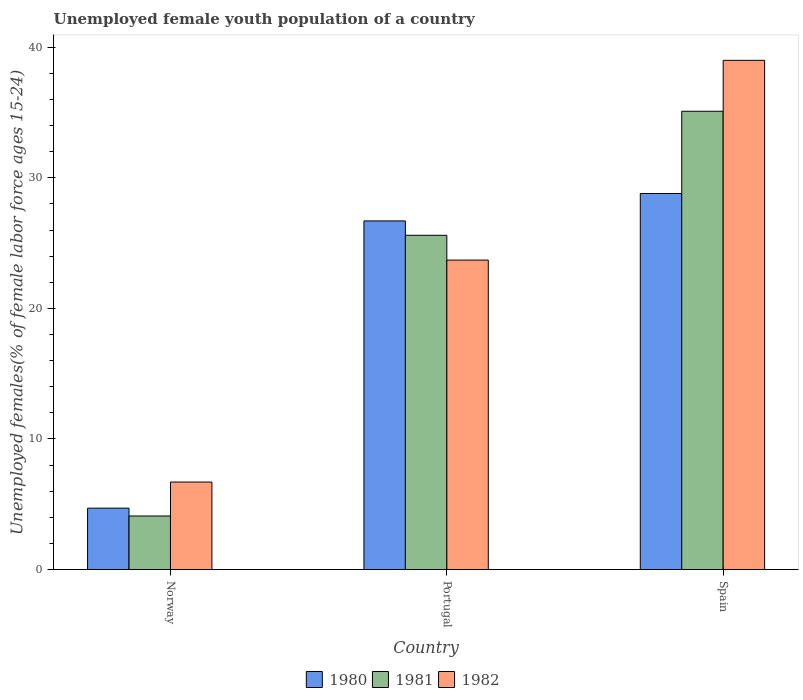Are the number of bars per tick equal to the number of legend labels?
Offer a very short reply. Yes. How many bars are there on the 1st tick from the left?
Offer a very short reply. 3. What is the percentage of unemployed female youth population in 1980 in Spain?
Your answer should be very brief. 28.8. Across all countries, what is the maximum percentage of unemployed female youth population in 1982?
Provide a short and direct response. 39. Across all countries, what is the minimum percentage of unemployed female youth population in 1982?
Your answer should be very brief. 6.7. In which country was the percentage of unemployed female youth population in 1981 maximum?
Offer a terse response. Spain. What is the total percentage of unemployed female youth population in 1980 in the graph?
Offer a terse response. 60.2. What is the difference between the percentage of unemployed female youth population in 1980 in Norway and that in Portugal?
Your response must be concise. -22. What is the difference between the percentage of unemployed female youth population in 1982 in Portugal and the percentage of unemployed female youth population in 1980 in Norway?
Your response must be concise. 19. What is the average percentage of unemployed female youth population in 1980 per country?
Offer a very short reply. 20.07. What is the difference between the percentage of unemployed female youth population of/in 1982 and percentage of unemployed female youth population of/in 1981 in Norway?
Your answer should be very brief. 2.6. In how many countries, is the percentage of unemployed female youth population in 1980 greater than 6 %?
Provide a succinct answer. 2. What is the ratio of the percentage of unemployed female youth population in 1980 in Norway to that in Portugal?
Make the answer very short. 0.18. Is the percentage of unemployed female youth population in 1981 in Portugal less than that in Spain?
Keep it short and to the point. Yes. Is the difference between the percentage of unemployed female youth population in 1982 in Norway and Portugal greater than the difference between the percentage of unemployed female youth population in 1981 in Norway and Portugal?
Keep it short and to the point. Yes. What is the difference between the highest and the second highest percentage of unemployed female youth population in 1981?
Ensure brevity in your answer.  -9.5. What is the difference between the highest and the lowest percentage of unemployed female youth population in 1980?
Your answer should be compact. 24.1. Is the sum of the percentage of unemployed female youth population in 1980 in Portugal and Spain greater than the maximum percentage of unemployed female youth population in 1981 across all countries?
Give a very brief answer. Yes. What does the 2nd bar from the left in Portugal represents?
Offer a terse response. 1981. Is it the case that in every country, the sum of the percentage of unemployed female youth population in 1980 and percentage of unemployed female youth population in 1982 is greater than the percentage of unemployed female youth population in 1981?
Your response must be concise. Yes. How many bars are there?
Your answer should be very brief. 9. How many countries are there in the graph?
Your answer should be compact. 3. Does the graph contain grids?
Give a very brief answer. No. How many legend labels are there?
Your response must be concise. 3. What is the title of the graph?
Your response must be concise. Unemployed female youth population of a country. Does "1966" appear as one of the legend labels in the graph?
Your answer should be compact. No. What is the label or title of the X-axis?
Your answer should be very brief. Country. What is the label or title of the Y-axis?
Give a very brief answer. Unemployed females(% of female labor force ages 15-24). What is the Unemployed females(% of female labor force ages 15-24) in 1980 in Norway?
Your answer should be very brief. 4.7. What is the Unemployed females(% of female labor force ages 15-24) in 1981 in Norway?
Offer a very short reply. 4.1. What is the Unemployed females(% of female labor force ages 15-24) of 1982 in Norway?
Your answer should be very brief. 6.7. What is the Unemployed females(% of female labor force ages 15-24) in 1980 in Portugal?
Offer a very short reply. 26.7. What is the Unemployed females(% of female labor force ages 15-24) of 1981 in Portugal?
Your answer should be compact. 25.6. What is the Unemployed females(% of female labor force ages 15-24) in 1982 in Portugal?
Give a very brief answer. 23.7. What is the Unemployed females(% of female labor force ages 15-24) of 1980 in Spain?
Offer a terse response. 28.8. What is the Unemployed females(% of female labor force ages 15-24) in 1981 in Spain?
Give a very brief answer. 35.1. What is the Unemployed females(% of female labor force ages 15-24) of 1982 in Spain?
Keep it short and to the point. 39. Across all countries, what is the maximum Unemployed females(% of female labor force ages 15-24) in 1980?
Offer a very short reply. 28.8. Across all countries, what is the maximum Unemployed females(% of female labor force ages 15-24) of 1981?
Make the answer very short. 35.1. Across all countries, what is the minimum Unemployed females(% of female labor force ages 15-24) in 1980?
Offer a terse response. 4.7. Across all countries, what is the minimum Unemployed females(% of female labor force ages 15-24) of 1981?
Offer a very short reply. 4.1. Across all countries, what is the minimum Unemployed females(% of female labor force ages 15-24) in 1982?
Make the answer very short. 6.7. What is the total Unemployed females(% of female labor force ages 15-24) in 1980 in the graph?
Your answer should be very brief. 60.2. What is the total Unemployed females(% of female labor force ages 15-24) in 1981 in the graph?
Your answer should be very brief. 64.8. What is the total Unemployed females(% of female labor force ages 15-24) in 1982 in the graph?
Your answer should be compact. 69.4. What is the difference between the Unemployed females(% of female labor force ages 15-24) of 1980 in Norway and that in Portugal?
Your answer should be very brief. -22. What is the difference between the Unemployed females(% of female labor force ages 15-24) in 1981 in Norway and that in Portugal?
Your response must be concise. -21.5. What is the difference between the Unemployed females(% of female labor force ages 15-24) of 1982 in Norway and that in Portugal?
Give a very brief answer. -17. What is the difference between the Unemployed females(% of female labor force ages 15-24) of 1980 in Norway and that in Spain?
Your response must be concise. -24.1. What is the difference between the Unemployed females(% of female labor force ages 15-24) of 1981 in Norway and that in Spain?
Your answer should be very brief. -31. What is the difference between the Unemployed females(% of female labor force ages 15-24) of 1982 in Norway and that in Spain?
Keep it short and to the point. -32.3. What is the difference between the Unemployed females(% of female labor force ages 15-24) of 1980 in Portugal and that in Spain?
Offer a very short reply. -2.1. What is the difference between the Unemployed females(% of female labor force ages 15-24) of 1982 in Portugal and that in Spain?
Provide a short and direct response. -15.3. What is the difference between the Unemployed females(% of female labor force ages 15-24) in 1980 in Norway and the Unemployed females(% of female labor force ages 15-24) in 1981 in Portugal?
Provide a short and direct response. -20.9. What is the difference between the Unemployed females(% of female labor force ages 15-24) in 1980 in Norway and the Unemployed females(% of female labor force ages 15-24) in 1982 in Portugal?
Offer a very short reply. -19. What is the difference between the Unemployed females(% of female labor force ages 15-24) of 1981 in Norway and the Unemployed females(% of female labor force ages 15-24) of 1982 in Portugal?
Your response must be concise. -19.6. What is the difference between the Unemployed females(% of female labor force ages 15-24) in 1980 in Norway and the Unemployed females(% of female labor force ages 15-24) in 1981 in Spain?
Offer a very short reply. -30.4. What is the difference between the Unemployed females(% of female labor force ages 15-24) of 1980 in Norway and the Unemployed females(% of female labor force ages 15-24) of 1982 in Spain?
Offer a very short reply. -34.3. What is the difference between the Unemployed females(% of female labor force ages 15-24) in 1981 in Norway and the Unemployed females(% of female labor force ages 15-24) in 1982 in Spain?
Offer a very short reply. -34.9. What is the difference between the Unemployed females(% of female labor force ages 15-24) in 1980 in Portugal and the Unemployed females(% of female labor force ages 15-24) in 1981 in Spain?
Ensure brevity in your answer.  -8.4. What is the difference between the Unemployed females(% of female labor force ages 15-24) in 1981 in Portugal and the Unemployed females(% of female labor force ages 15-24) in 1982 in Spain?
Offer a very short reply. -13.4. What is the average Unemployed females(% of female labor force ages 15-24) of 1980 per country?
Your answer should be very brief. 20.07. What is the average Unemployed females(% of female labor force ages 15-24) in 1981 per country?
Give a very brief answer. 21.6. What is the average Unemployed females(% of female labor force ages 15-24) in 1982 per country?
Provide a succinct answer. 23.13. What is the difference between the Unemployed females(% of female labor force ages 15-24) of 1981 and Unemployed females(% of female labor force ages 15-24) of 1982 in Norway?
Your answer should be compact. -2.6. What is the difference between the Unemployed females(% of female labor force ages 15-24) of 1980 and Unemployed females(% of female labor force ages 15-24) of 1982 in Portugal?
Keep it short and to the point. 3. What is the difference between the Unemployed females(% of female labor force ages 15-24) of 1980 and Unemployed females(% of female labor force ages 15-24) of 1982 in Spain?
Offer a terse response. -10.2. What is the ratio of the Unemployed females(% of female labor force ages 15-24) in 1980 in Norway to that in Portugal?
Your answer should be compact. 0.18. What is the ratio of the Unemployed females(% of female labor force ages 15-24) of 1981 in Norway to that in Portugal?
Your response must be concise. 0.16. What is the ratio of the Unemployed females(% of female labor force ages 15-24) in 1982 in Norway to that in Portugal?
Your answer should be very brief. 0.28. What is the ratio of the Unemployed females(% of female labor force ages 15-24) in 1980 in Norway to that in Spain?
Make the answer very short. 0.16. What is the ratio of the Unemployed females(% of female labor force ages 15-24) in 1981 in Norway to that in Spain?
Give a very brief answer. 0.12. What is the ratio of the Unemployed females(% of female labor force ages 15-24) in 1982 in Norway to that in Spain?
Provide a succinct answer. 0.17. What is the ratio of the Unemployed females(% of female labor force ages 15-24) in 1980 in Portugal to that in Spain?
Offer a terse response. 0.93. What is the ratio of the Unemployed females(% of female labor force ages 15-24) in 1981 in Portugal to that in Spain?
Your response must be concise. 0.73. What is the ratio of the Unemployed females(% of female labor force ages 15-24) of 1982 in Portugal to that in Spain?
Make the answer very short. 0.61. What is the difference between the highest and the second highest Unemployed females(% of female labor force ages 15-24) of 1980?
Ensure brevity in your answer.  2.1. What is the difference between the highest and the second highest Unemployed females(% of female labor force ages 15-24) in 1981?
Your answer should be very brief. 9.5. What is the difference between the highest and the lowest Unemployed females(% of female labor force ages 15-24) in 1980?
Make the answer very short. 24.1. What is the difference between the highest and the lowest Unemployed females(% of female labor force ages 15-24) in 1982?
Your response must be concise. 32.3. 